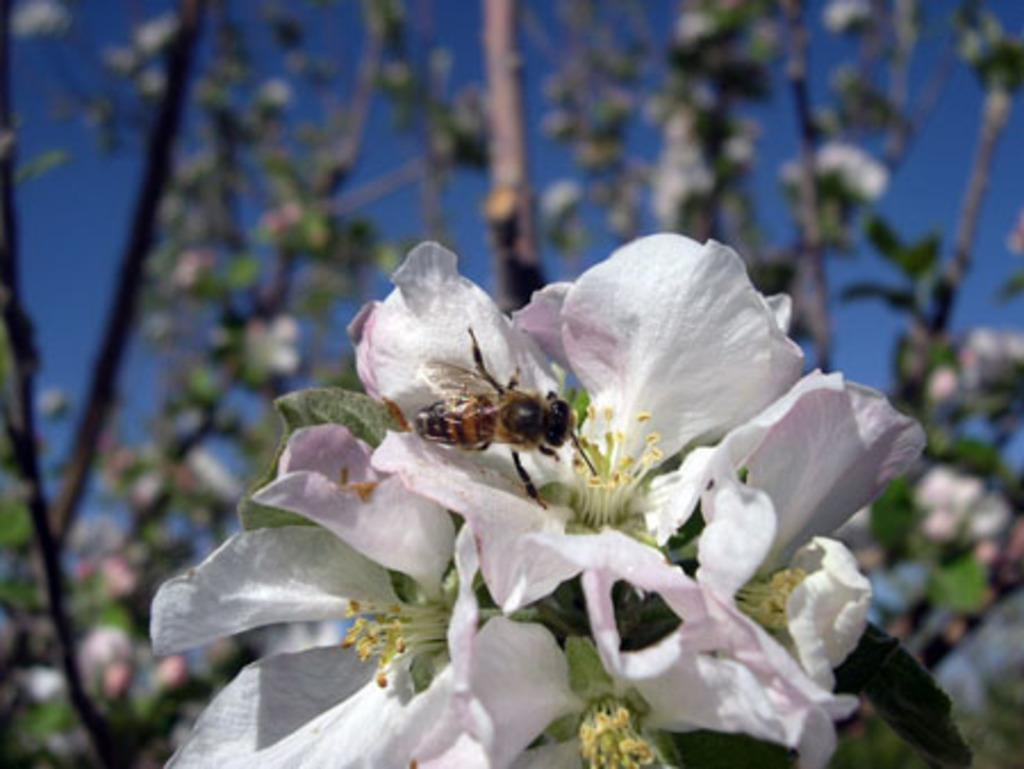What color are the flowers on the plants in the image? The flowers on the plants in the image are white. What can be seen on one of the flowers in the foreground of the image? There is a honey bee on a flower in the foreground of the image. What is visible at the top of the image? The sky is visible at the top of the image. What type of work is the doll doing in the image? There is no doll present in the image, so it cannot be determined what work the doll might be doing. 